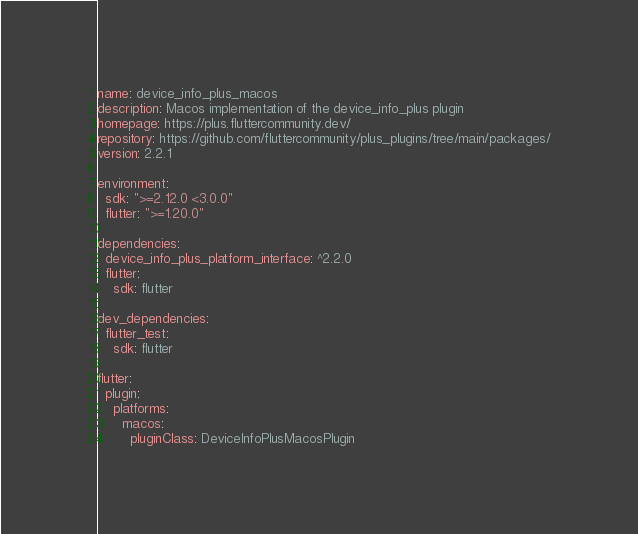<code> <loc_0><loc_0><loc_500><loc_500><_YAML_>name: device_info_plus_macos
description: Macos implementation of the device_info_plus plugin
homepage: https://plus.fluttercommunity.dev/
repository: https://github.com/fluttercommunity/plus_plugins/tree/main/packages/
version: 2.2.1

environment:
  sdk: ">=2.12.0 <3.0.0"
  flutter: ">=1.20.0"

dependencies:
  device_info_plus_platform_interface: ^2.2.0
  flutter:
    sdk: flutter

dev_dependencies:
  flutter_test:
    sdk: flutter

flutter:
  plugin:
    platforms:
      macos:
        pluginClass: DeviceInfoPlusMacosPlugin
</code> 